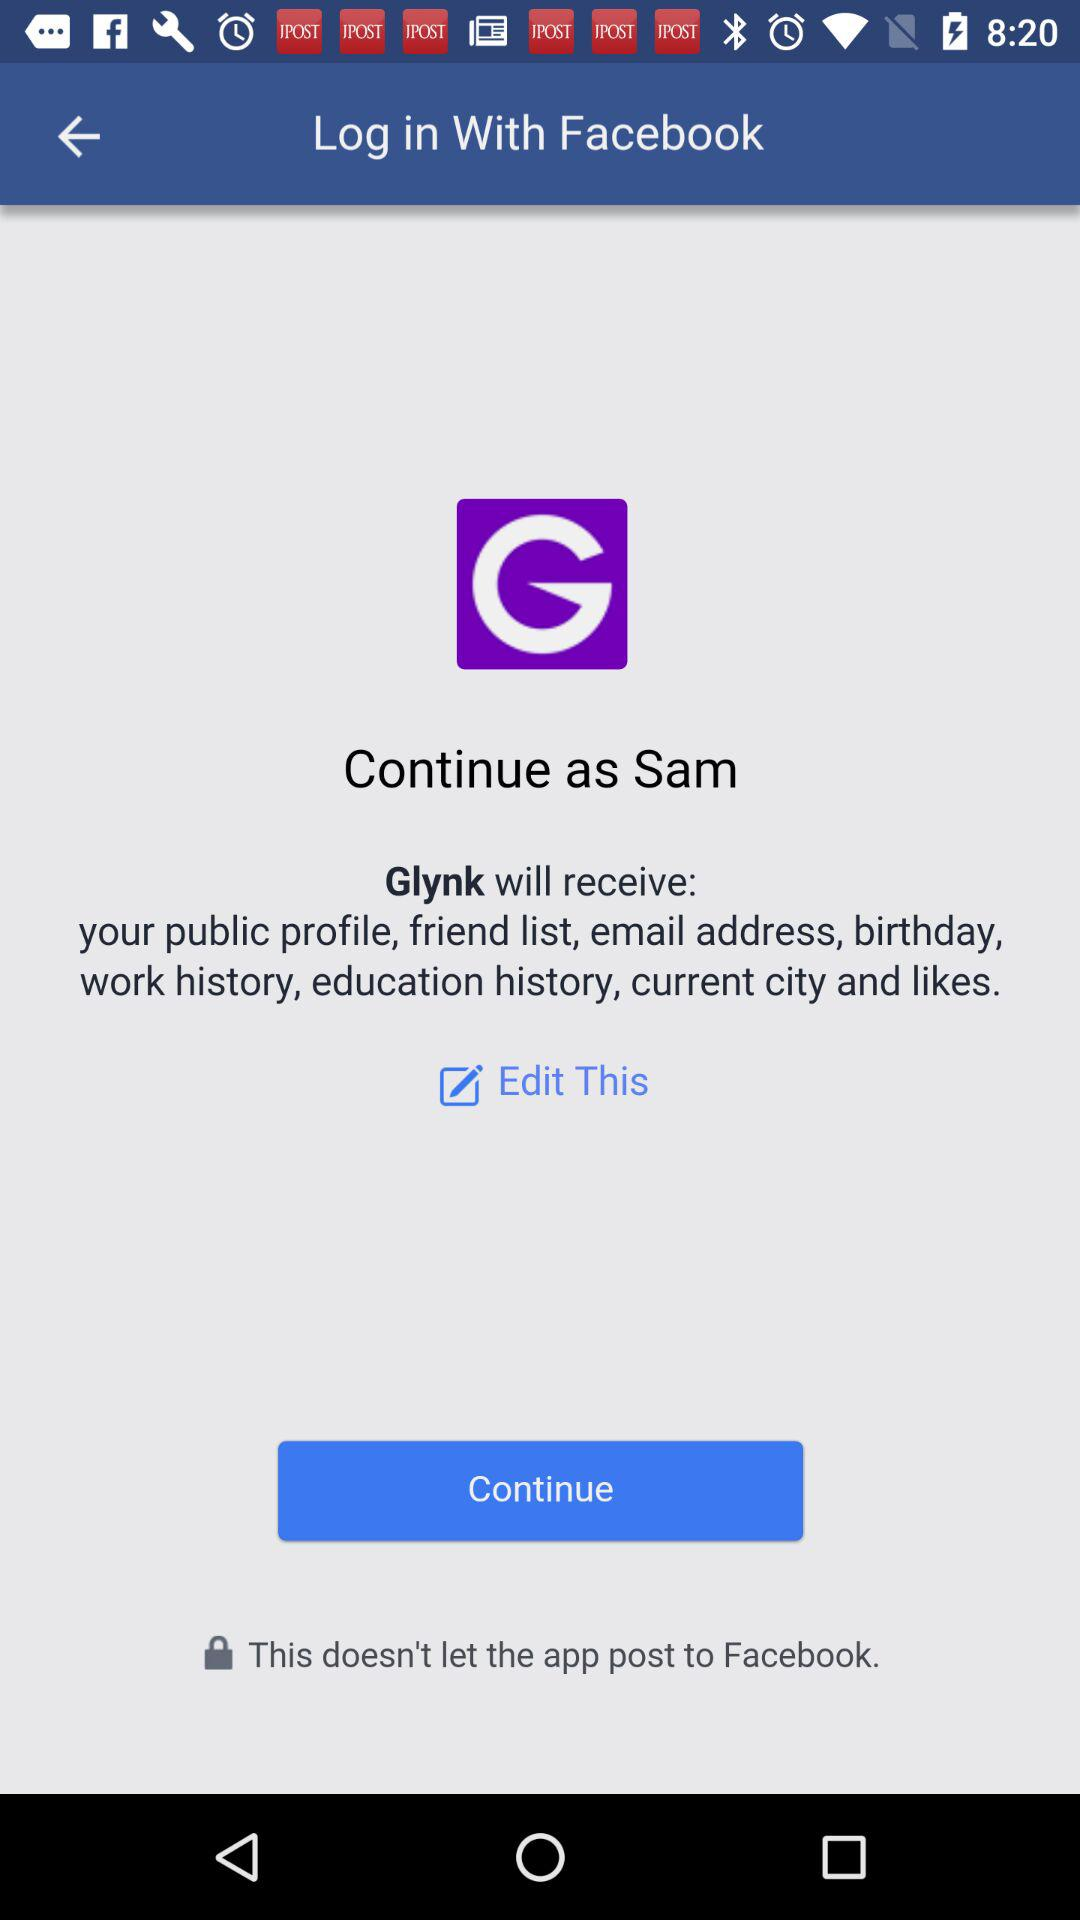Who will receive the public profile and email address? The public profile and email address will be received by "Glynk". 